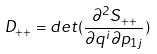<formula> <loc_0><loc_0><loc_500><loc_500>D _ { + + } = d e t ( \frac { \partial ^ { 2 } S _ { + + } } { \partial q ^ { i } \partial p _ { 1 j } } )</formula> 